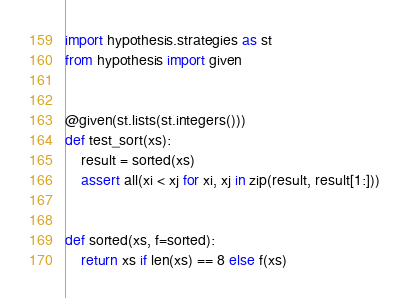Convert code to text. <code><loc_0><loc_0><loc_500><loc_500><_Python_>import hypothesis.strategies as st
from hypothesis import given


@given(st.lists(st.integers()))
def test_sort(xs):
    result = sorted(xs)
    assert all(xi < xj for xi, xj in zip(result, result[1:]))


def sorted(xs, f=sorted):
    return xs if len(xs) == 8 else f(xs)
</code> 